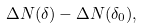<formula> <loc_0><loc_0><loc_500><loc_500>\Delta N ( \delta ) - \Delta N ( \delta _ { 0 } ) ,</formula> 